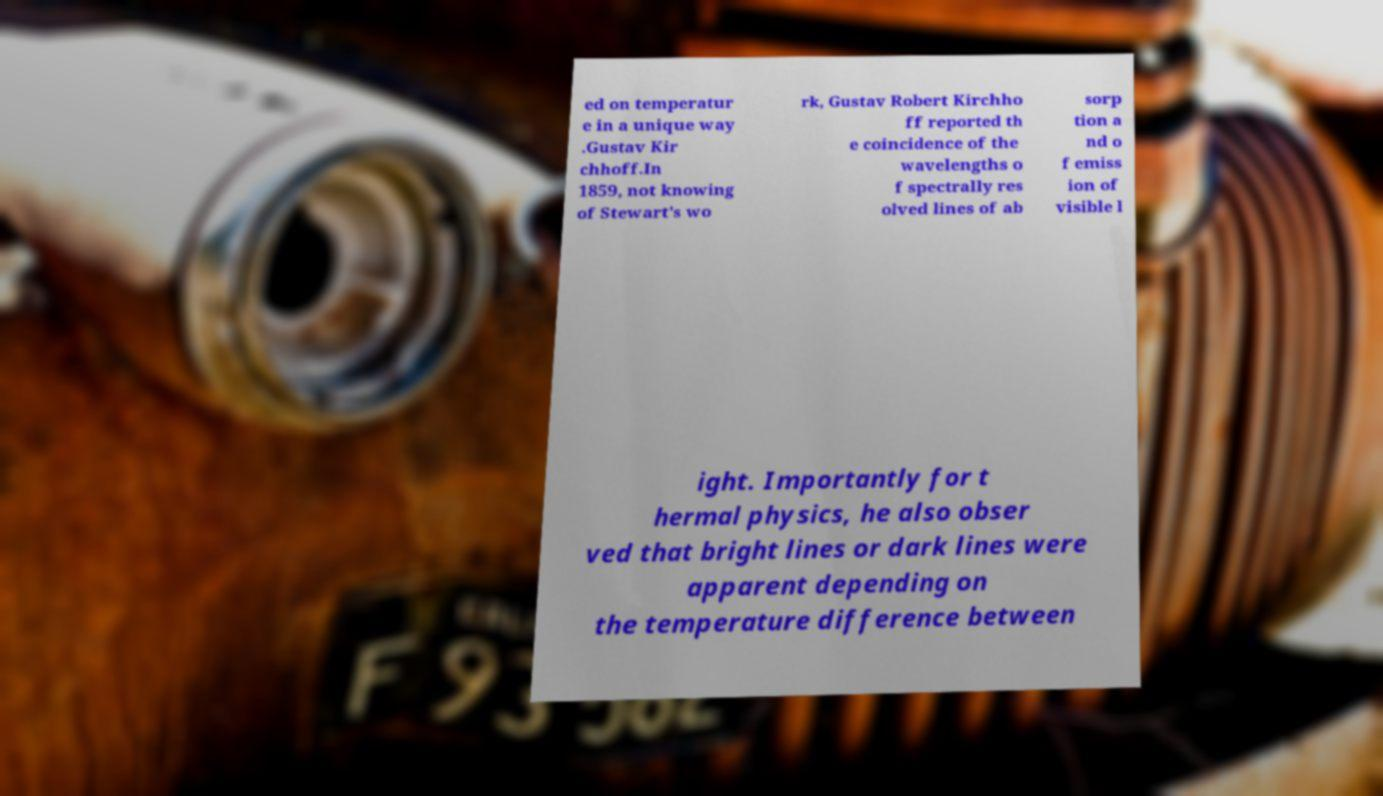Can you accurately transcribe the text from the provided image for me? ed on temperatur e in a unique way .Gustav Kir chhoff.In 1859, not knowing of Stewart's wo rk, Gustav Robert Kirchho ff reported th e coincidence of the wavelengths o f spectrally res olved lines of ab sorp tion a nd o f emiss ion of visible l ight. Importantly for t hermal physics, he also obser ved that bright lines or dark lines were apparent depending on the temperature difference between 